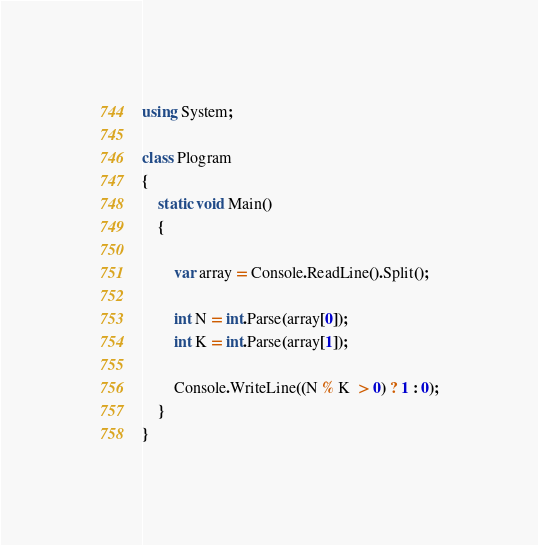<code> <loc_0><loc_0><loc_500><loc_500><_C#_>using System;

class Plogram
{
    static void Main()
    {

        var array = Console.ReadLine().Split();

        int N = int.Parse(array[0]);
        int K = int.Parse(array[1]);

        Console.WriteLine((N % K  > 0) ? 1 : 0);
    }
}</code> 